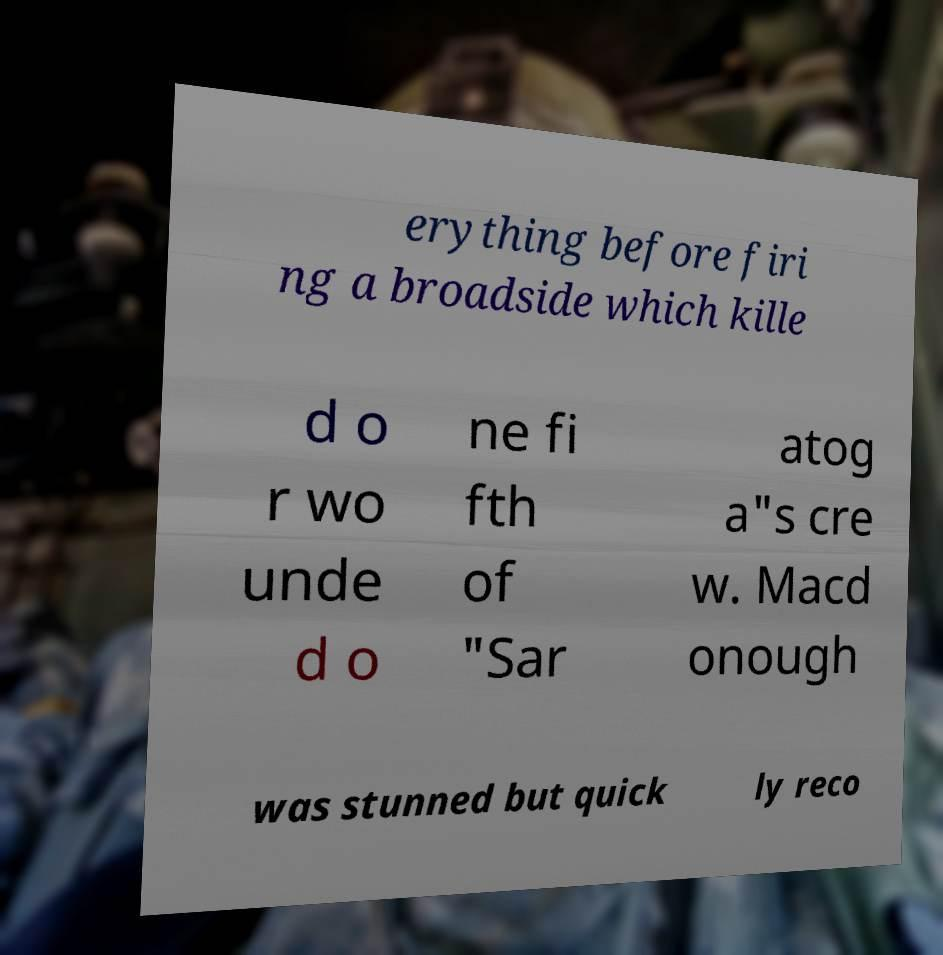Can you read and provide the text displayed in the image?This photo seems to have some interesting text. Can you extract and type it out for me? erything before firi ng a broadside which kille d o r wo unde d o ne fi fth of "Sar atog a"s cre w. Macd onough was stunned but quick ly reco 